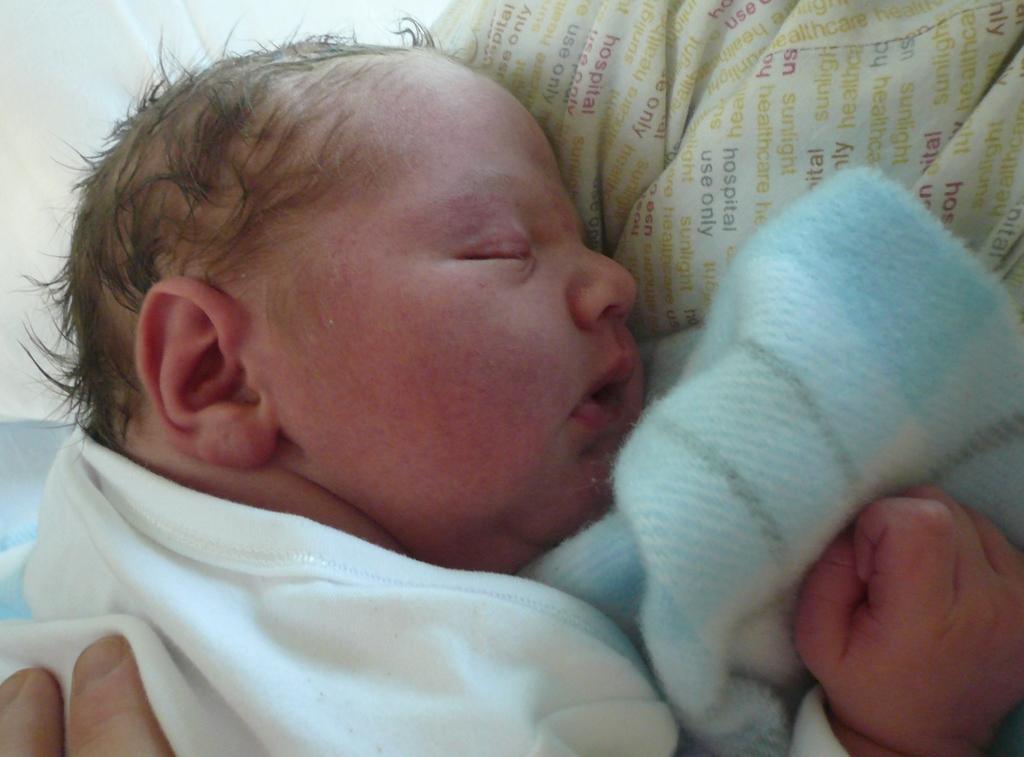In one or two sentences, can you explain what this image depicts? In this image we can see a baby sleeping on a cloth with text. Also there is another cloth. And we can see fingers in the left bottom corner. 